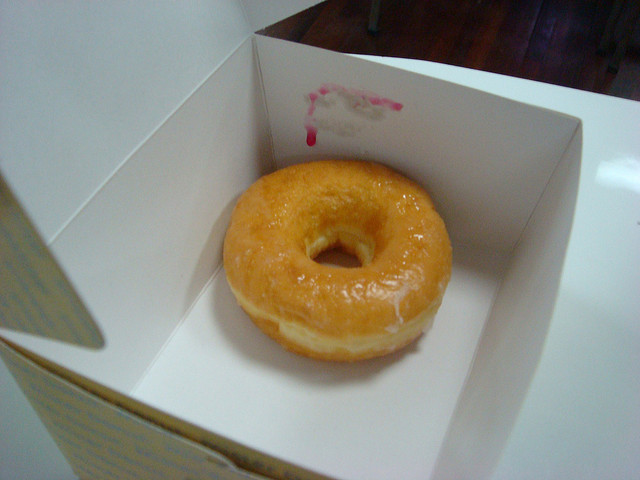How many donuts is there? There is one donut in the box. It looks like a classic glazed variety with a shiny and sugary coating, tempting to anyone with a sweet tooth! 